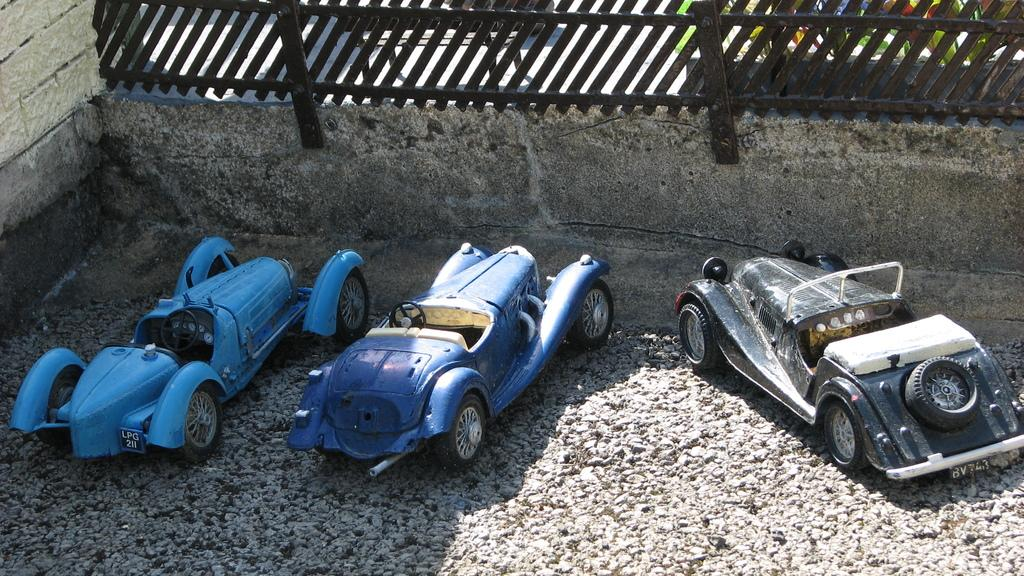What type of objects are present in the image? There are toy vehicles in the image. How are the toy vehicles positioned in the image? The toy vehicles are parked on the ground. What can be seen at the top of the image? There is a fence, plants, and a wall visible at the top of the image. How does the pig turn the cannon in the image? There is no pig or cannon present in the image. 